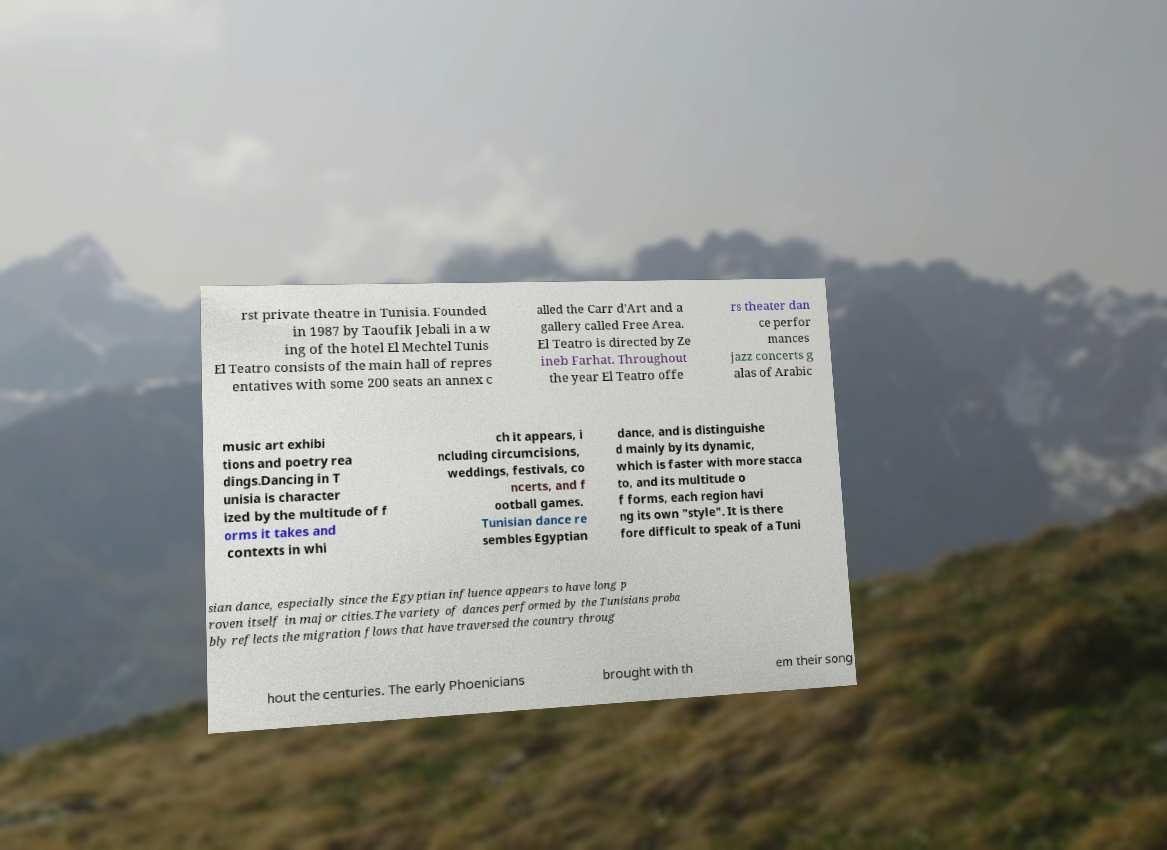What messages or text are displayed in this image? I need them in a readable, typed format. rst private theatre in Tunisia. Founded in 1987 by Taoufik Jebali in a w ing of the hotel El Mechtel Tunis El Teatro consists of the main hall of repres entatives with some 200 seats an annex c alled the Carr d'Art and a gallery called Free Area. El Teatro is directed by Ze ineb Farhat. Throughout the year El Teatro offe rs theater dan ce perfor mances jazz concerts g alas of Arabic music art exhibi tions and poetry rea dings.Dancing in T unisia is character ized by the multitude of f orms it takes and contexts in whi ch it appears, i ncluding circumcisions, weddings, festivals, co ncerts, and f ootball games. Tunisian dance re sembles Egyptian dance, and is distinguishe d mainly by its dynamic, which is faster with more stacca to, and its multitude o f forms, each region havi ng its own "style". It is there fore difficult to speak of a Tuni sian dance, especially since the Egyptian influence appears to have long p roven itself in major cities.The variety of dances performed by the Tunisians proba bly reflects the migration flows that have traversed the country throug hout the centuries. The early Phoenicians brought with th em their song 